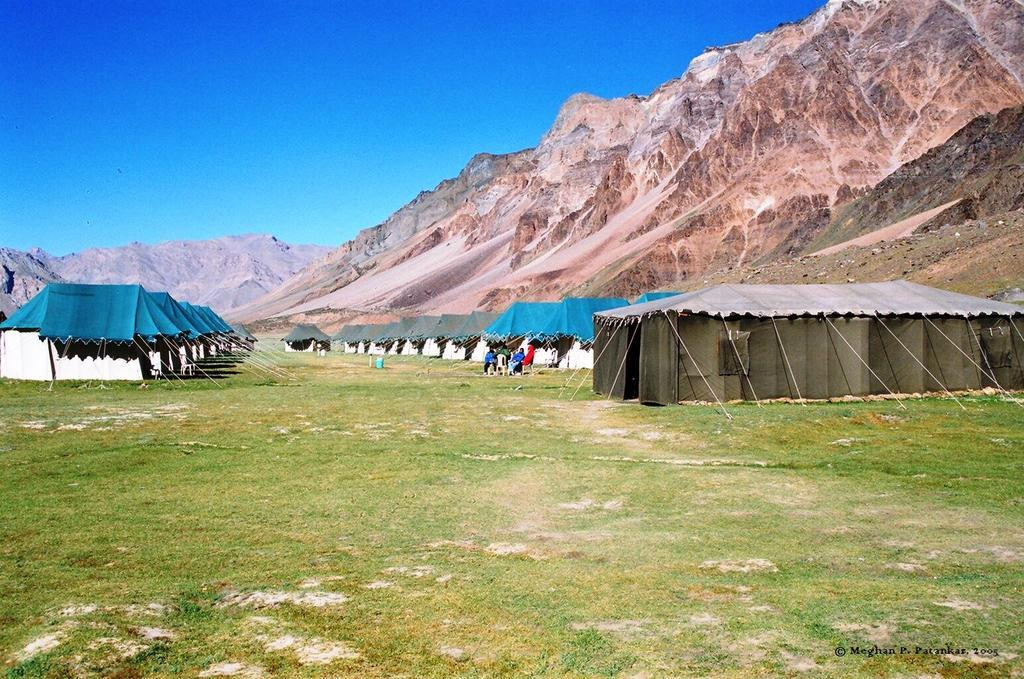What type of temporary shelters can be seen in the image? There are tents in the image. What are the people in the image using for seating? People are sitting on chairs in the image. What type of natural landform is visible in the background of the image? There are hills visible in the background of the image. What is visible at the top of the image? The sky is visible at the top of the image. How many chickens are roaming around the tents in the image? There are no chickens present in the image. What type of beam is supporting the chairs in the image? There is no beam visible in the image; the chairs are simply placed on the ground. 